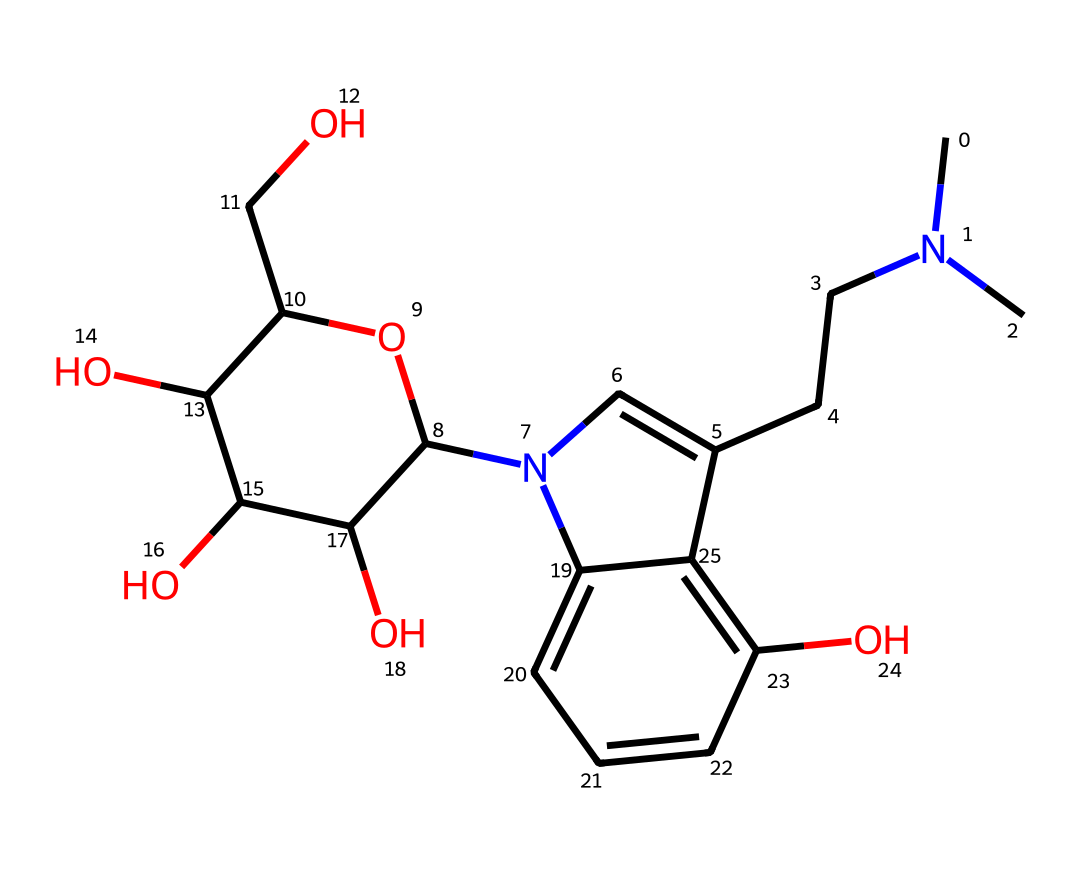What is the molecular formula of psilocybin? To determine the molecular formula, we count the different atoms in the structure. The SMILES representation shows carbon (C), hydrogen (H), nitrogen (N), and oxygen (O) atoms. By counting: 12 carbon, 17 hydrogen, 2 nitrogen, and 4 oxygen atoms, we find the molecular formula.
Answer: C12H17N2O4P How many rings are present in the psilocybin structure? By examining the chemical structure, we identify two distinct ring structures that are part of the core of psilocybin. One is a bicyclic system composed of a nitrogen-containing ring and a benzene ring.
Answer: 2 Which element in the structure is responsible for the nitrogen atom's electron density? The nitrogen atom's electron density is mainly influenced by its covalent bonds with surrounding carbon atoms, as well as its lone pair of electrons, which are a characteristic feature of amino-based structures.
Answer: nitrogen Does psilocybin contain a hydroxyl group, and if so, how many? The visual representation indicates the presence of hydroxyl groups (–OH) attached to the benzene ring and other carbon structures, which are key for its reactivity and solubility. Counting these groups reveals their number.
Answer: 3 What type of functional groups are present in psilocybin? By analyzing the structure, we can identify that psilocybin contains several functional groups, the most notable being a phosphate group, hydroxyl groups, and an amine group. This highlights its biochemical properties.
Answer: phosphate, hydroxyl, amine 